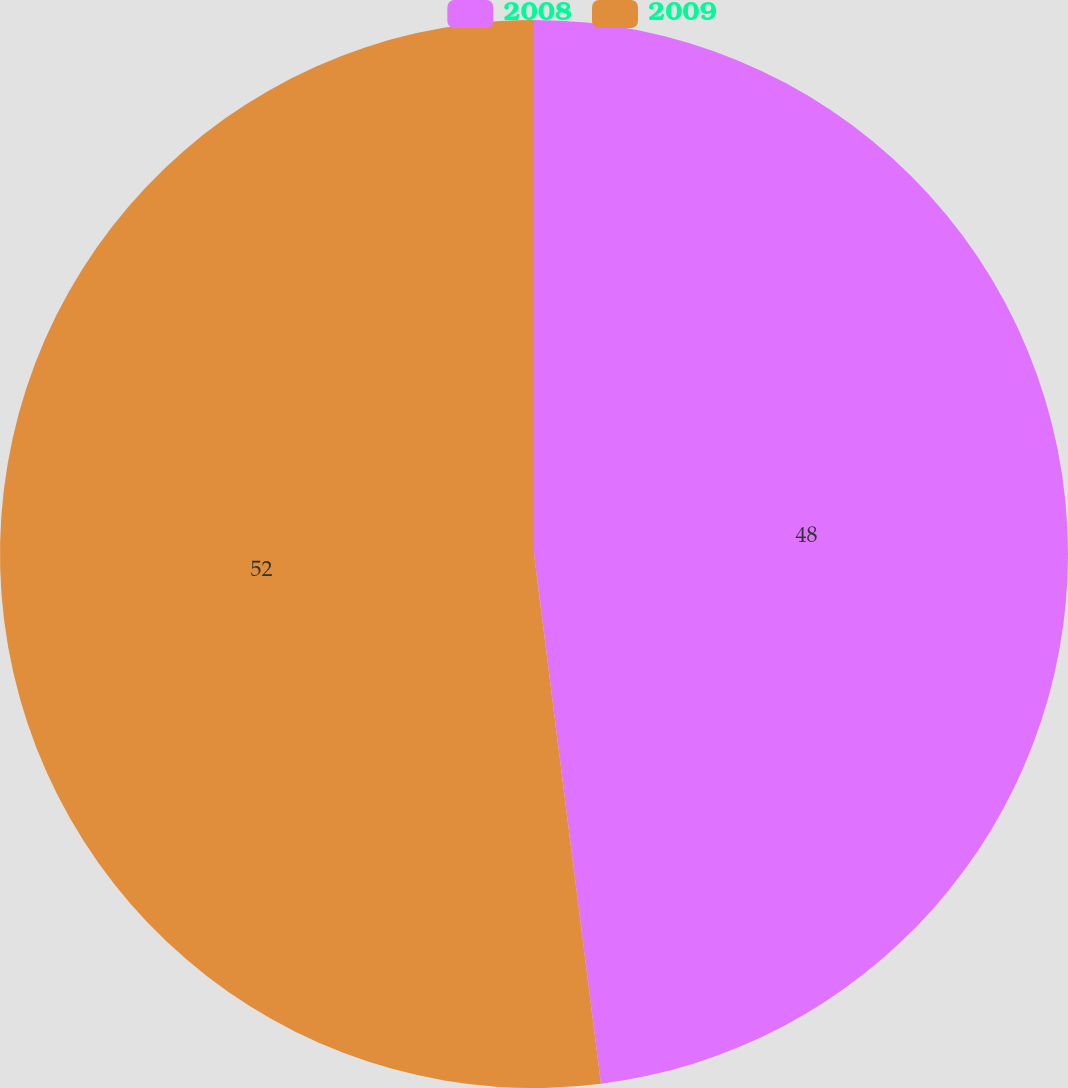Convert chart. <chart><loc_0><loc_0><loc_500><loc_500><pie_chart><fcel>2008<fcel>2009<nl><fcel>48.0%<fcel>52.0%<nl></chart> 